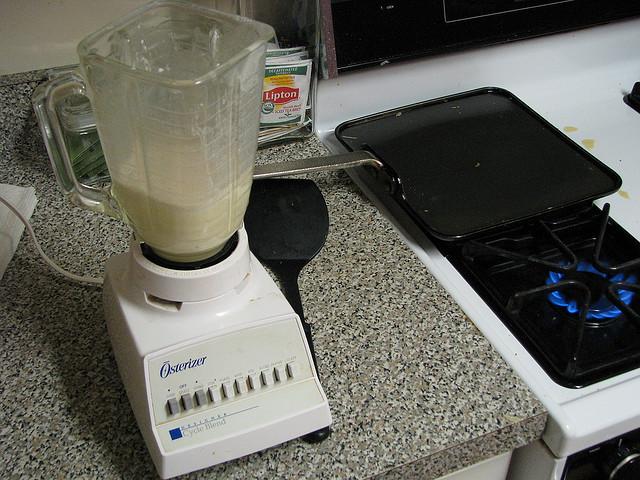Is this a gas stove?
Concise answer only. Yes. Are these edible objects high in fat?
Short answer required. No. What color is the liquid in the blender?
Give a very brief answer. White. What color is the blender on the counter?
Give a very brief answer. White. Is the blender plugged in?
Be succinct. Yes. Would it be safe to put your hand on the stove?
Keep it brief. No. 